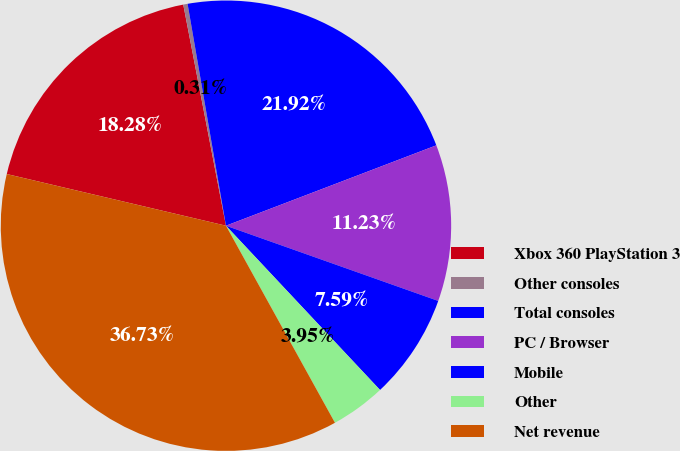Convert chart. <chart><loc_0><loc_0><loc_500><loc_500><pie_chart><fcel>Xbox 360 PlayStation 3<fcel>Other consoles<fcel>Total consoles<fcel>PC / Browser<fcel>Mobile<fcel>Other<fcel>Net revenue<nl><fcel>18.28%<fcel>0.31%<fcel>21.92%<fcel>11.23%<fcel>7.59%<fcel>3.95%<fcel>36.73%<nl></chart> 